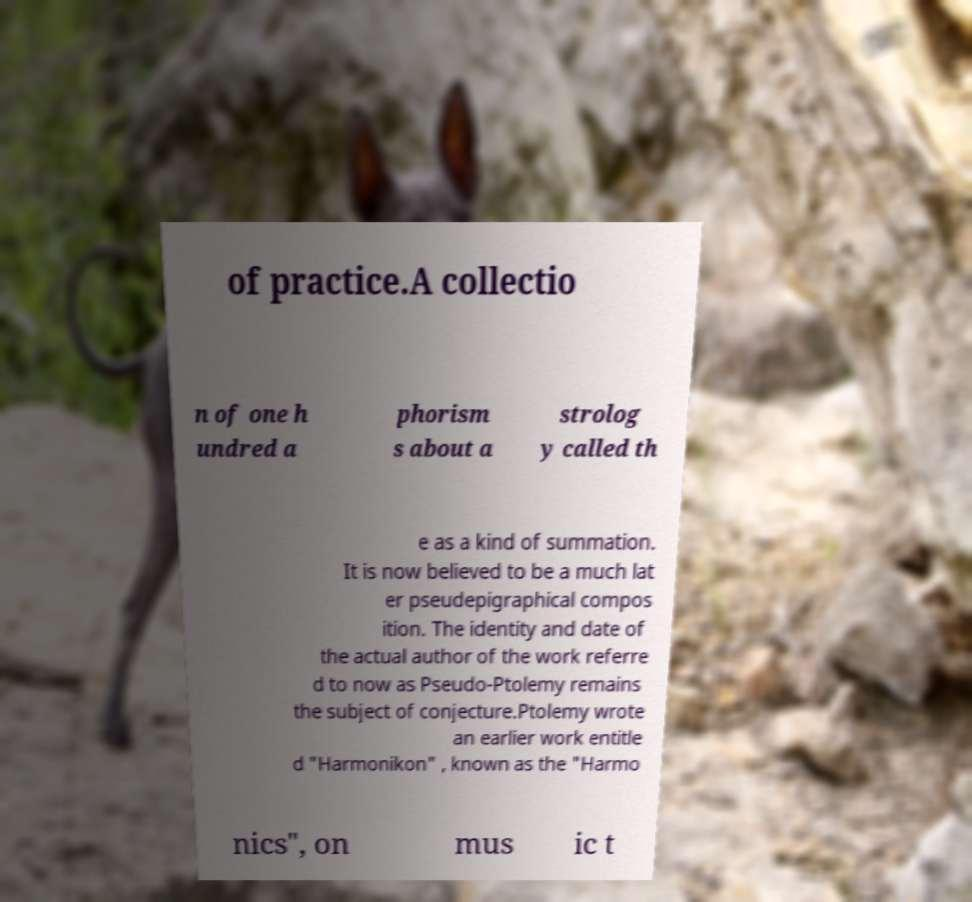For documentation purposes, I need the text within this image transcribed. Could you provide that? of practice.A collectio n of one h undred a phorism s about a strolog y called th e as a kind of summation. It is now believed to be a much lat er pseudepigraphical compos ition. The identity and date of the actual author of the work referre d to now as Pseudo-Ptolemy remains the subject of conjecture.Ptolemy wrote an earlier work entitle d "Harmonikon" , known as the "Harmo nics", on mus ic t 